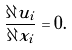<formula> <loc_0><loc_0><loc_500><loc_500>\frac { \partial u _ { i } } { \partial x _ { i } } = 0 .</formula> 